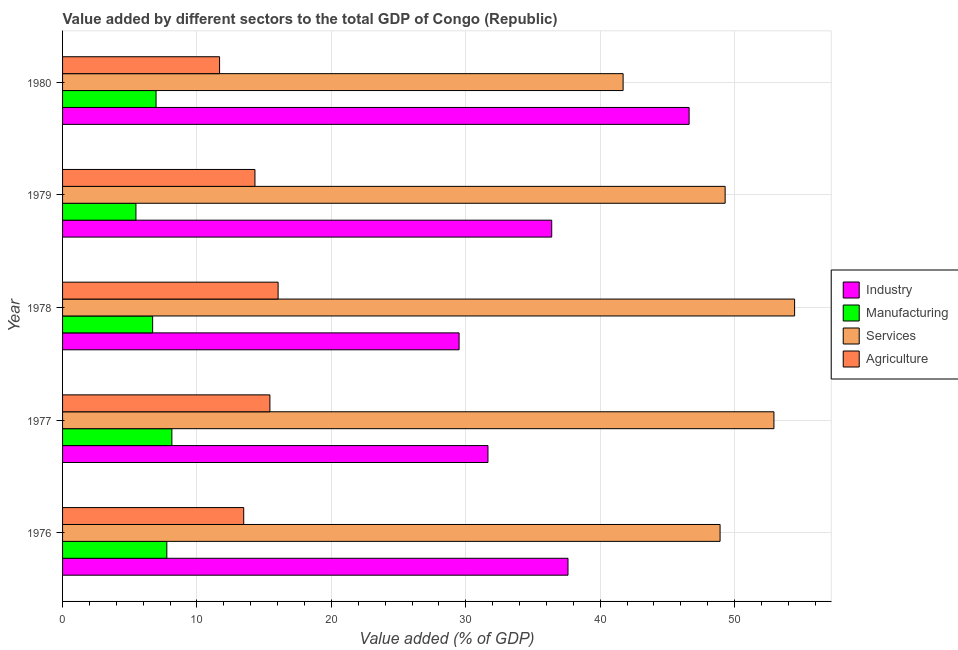How many groups of bars are there?
Provide a short and direct response. 5. Are the number of bars per tick equal to the number of legend labels?
Your response must be concise. Yes. Are the number of bars on each tick of the Y-axis equal?
Make the answer very short. Yes. What is the label of the 2nd group of bars from the top?
Make the answer very short. 1979. What is the value added by industrial sector in 1976?
Give a very brief answer. 37.6. Across all years, what is the maximum value added by services sector?
Provide a short and direct response. 54.46. Across all years, what is the minimum value added by industrial sector?
Offer a terse response. 29.5. In which year was the value added by agricultural sector maximum?
Make the answer very short. 1978. In which year was the value added by industrial sector minimum?
Give a very brief answer. 1978. What is the total value added by manufacturing sector in the graph?
Give a very brief answer. 35.01. What is the difference between the value added by industrial sector in 1977 and that in 1979?
Your answer should be very brief. -4.74. What is the difference between the value added by manufacturing sector in 1980 and the value added by industrial sector in 1979?
Offer a very short reply. -29.44. What is the average value added by manufacturing sector per year?
Your response must be concise. 7. In the year 1979, what is the difference between the value added by agricultural sector and value added by services sector?
Keep it short and to the point. -34.98. In how many years, is the value added by manufacturing sector greater than 42 %?
Make the answer very short. 0. Is the value added by services sector in 1978 less than that in 1979?
Your answer should be compact. No. What is the difference between the highest and the second highest value added by industrial sector?
Offer a very short reply. 9.01. What is the difference between the highest and the lowest value added by services sector?
Ensure brevity in your answer.  12.76. Is the sum of the value added by agricultural sector in 1976 and 1979 greater than the maximum value added by manufacturing sector across all years?
Your answer should be very brief. Yes. Is it the case that in every year, the sum of the value added by manufacturing sector and value added by agricultural sector is greater than the sum of value added by industrial sector and value added by services sector?
Ensure brevity in your answer.  No. What does the 1st bar from the top in 1977 represents?
Keep it short and to the point. Agriculture. What does the 2nd bar from the bottom in 1976 represents?
Give a very brief answer. Manufacturing. Is it the case that in every year, the sum of the value added by industrial sector and value added by manufacturing sector is greater than the value added by services sector?
Keep it short and to the point. No. Are all the bars in the graph horizontal?
Your answer should be compact. Yes. How many years are there in the graph?
Your answer should be very brief. 5. Does the graph contain any zero values?
Offer a terse response. No. Does the graph contain grids?
Your answer should be very brief. Yes. Where does the legend appear in the graph?
Your answer should be compact. Center right. How many legend labels are there?
Offer a terse response. 4. How are the legend labels stacked?
Your response must be concise. Vertical. What is the title of the graph?
Your answer should be very brief. Value added by different sectors to the total GDP of Congo (Republic). Does "Secondary vocational" appear as one of the legend labels in the graph?
Your answer should be compact. No. What is the label or title of the X-axis?
Offer a very short reply. Value added (% of GDP). What is the label or title of the Y-axis?
Your answer should be very brief. Year. What is the Value added (% of GDP) in Industry in 1976?
Your response must be concise. 37.6. What is the Value added (% of GDP) of Manufacturing in 1976?
Provide a succinct answer. 7.76. What is the Value added (% of GDP) in Services in 1976?
Your answer should be very brief. 48.92. What is the Value added (% of GDP) of Agriculture in 1976?
Your answer should be compact. 13.48. What is the Value added (% of GDP) in Industry in 1977?
Your answer should be compact. 31.65. What is the Value added (% of GDP) of Manufacturing in 1977?
Provide a succinct answer. 8.13. What is the Value added (% of GDP) of Services in 1977?
Make the answer very short. 52.93. What is the Value added (% of GDP) in Agriculture in 1977?
Offer a terse response. 15.43. What is the Value added (% of GDP) in Industry in 1978?
Make the answer very short. 29.5. What is the Value added (% of GDP) in Manufacturing in 1978?
Offer a terse response. 6.7. What is the Value added (% of GDP) in Services in 1978?
Make the answer very short. 54.46. What is the Value added (% of GDP) of Agriculture in 1978?
Offer a terse response. 16.04. What is the Value added (% of GDP) in Industry in 1979?
Offer a terse response. 36.39. What is the Value added (% of GDP) in Manufacturing in 1979?
Your answer should be very brief. 5.46. What is the Value added (% of GDP) of Services in 1979?
Keep it short and to the point. 49.29. What is the Value added (% of GDP) in Agriculture in 1979?
Keep it short and to the point. 14.31. What is the Value added (% of GDP) of Industry in 1980?
Provide a short and direct response. 46.61. What is the Value added (% of GDP) of Manufacturing in 1980?
Your answer should be compact. 6.96. What is the Value added (% of GDP) in Services in 1980?
Offer a terse response. 41.7. What is the Value added (% of GDP) in Agriculture in 1980?
Ensure brevity in your answer.  11.68. Across all years, what is the maximum Value added (% of GDP) in Industry?
Make the answer very short. 46.61. Across all years, what is the maximum Value added (% of GDP) in Manufacturing?
Your answer should be very brief. 8.13. Across all years, what is the maximum Value added (% of GDP) of Services?
Provide a succinct answer. 54.46. Across all years, what is the maximum Value added (% of GDP) of Agriculture?
Your answer should be very brief. 16.04. Across all years, what is the minimum Value added (% of GDP) in Industry?
Make the answer very short. 29.5. Across all years, what is the minimum Value added (% of GDP) of Manufacturing?
Offer a terse response. 5.46. Across all years, what is the minimum Value added (% of GDP) in Services?
Offer a terse response. 41.7. Across all years, what is the minimum Value added (% of GDP) in Agriculture?
Your response must be concise. 11.68. What is the total Value added (% of GDP) of Industry in the graph?
Your answer should be compact. 181.76. What is the total Value added (% of GDP) in Manufacturing in the graph?
Make the answer very short. 35.01. What is the total Value added (% of GDP) in Services in the graph?
Offer a very short reply. 247.3. What is the total Value added (% of GDP) in Agriculture in the graph?
Provide a succinct answer. 70.93. What is the difference between the Value added (% of GDP) of Industry in 1976 and that in 1977?
Ensure brevity in your answer.  5.96. What is the difference between the Value added (% of GDP) in Manufacturing in 1976 and that in 1977?
Make the answer very short. -0.38. What is the difference between the Value added (% of GDP) in Services in 1976 and that in 1977?
Ensure brevity in your answer.  -4.01. What is the difference between the Value added (% of GDP) in Agriculture in 1976 and that in 1977?
Keep it short and to the point. -1.95. What is the difference between the Value added (% of GDP) in Industry in 1976 and that in 1978?
Keep it short and to the point. 8.1. What is the difference between the Value added (% of GDP) of Manufacturing in 1976 and that in 1978?
Ensure brevity in your answer.  1.06. What is the difference between the Value added (% of GDP) in Services in 1976 and that in 1978?
Make the answer very short. -5.54. What is the difference between the Value added (% of GDP) in Agriculture in 1976 and that in 1978?
Offer a terse response. -2.56. What is the difference between the Value added (% of GDP) in Industry in 1976 and that in 1979?
Ensure brevity in your answer.  1.21. What is the difference between the Value added (% of GDP) of Manufacturing in 1976 and that in 1979?
Ensure brevity in your answer.  2.3. What is the difference between the Value added (% of GDP) of Services in 1976 and that in 1979?
Make the answer very short. -0.38. What is the difference between the Value added (% of GDP) of Agriculture in 1976 and that in 1979?
Make the answer very short. -0.84. What is the difference between the Value added (% of GDP) in Industry in 1976 and that in 1980?
Keep it short and to the point. -9.01. What is the difference between the Value added (% of GDP) in Manufacturing in 1976 and that in 1980?
Your answer should be very brief. 0.8. What is the difference between the Value added (% of GDP) in Services in 1976 and that in 1980?
Offer a terse response. 7.21. What is the difference between the Value added (% of GDP) of Agriculture in 1976 and that in 1980?
Ensure brevity in your answer.  1.8. What is the difference between the Value added (% of GDP) in Industry in 1977 and that in 1978?
Your answer should be very brief. 2.15. What is the difference between the Value added (% of GDP) of Manufacturing in 1977 and that in 1978?
Keep it short and to the point. 1.43. What is the difference between the Value added (% of GDP) of Services in 1977 and that in 1978?
Give a very brief answer. -1.54. What is the difference between the Value added (% of GDP) in Agriculture in 1977 and that in 1978?
Your answer should be very brief. -0.61. What is the difference between the Value added (% of GDP) of Industry in 1977 and that in 1979?
Your response must be concise. -4.74. What is the difference between the Value added (% of GDP) in Manufacturing in 1977 and that in 1979?
Provide a succinct answer. 2.67. What is the difference between the Value added (% of GDP) of Services in 1977 and that in 1979?
Your response must be concise. 3.63. What is the difference between the Value added (% of GDP) of Agriculture in 1977 and that in 1979?
Provide a short and direct response. 1.11. What is the difference between the Value added (% of GDP) in Industry in 1977 and that in 1980?
Provide a short and direct response. -14.97. What is the difference between the Value added (% of GDP) of Manufacturing in 1977 and that in 1980?
Your response must be concise. 1.18. What is the difference between the Value added (% of GDP) of Services in 1977 and that in 1980?
Your answer should be compact. 11.22. What is the difference between the Value added (% of GDP) of Agriculture in 1977 and that in 1980?
Your answer should be very brief. 3.74. What is the difference between the Value added (% of GDP) in Industry in 1978 and that in 1979?
Keep it short and to the point. -6.89. What is the difference between the Value added (% of GDP) of Manufacturing in 1978 and that in 1979?
Keep it short and to the point. 1.24. What is the difference between the Value added (% of GDP) in Services in 1978 and that in 1979?
Offer a very short reply. 5.17. What is the difference between the Value added (% of GDP) of Agriculture in 1978 and that in 1979?
Make the answer very short. 1.72. What is the difference between the Value added (% of GDP) in Industry in 1978 and that in 1980?
Give a very brief answer. -17.11. What is the difference between the Value added (% of GDP) of Manufacturing in 1978 and that in 1980?
Your answer should be compact. -0.25. What is the difference between the Value added (% of GDP) of Services in 1978 and that in 1980?
Keep it short and to the point. 12.76. What is the difference between the Value added (% of GDP) in Agriculture in 1978 and that in 1980?
Your answer should be compact. 4.35. What is the difference between the Value added (% of GDP) in Industry in 1979 and that in 1980?
Offer a very short reply. -10.22. What is the difference between the Value added (% of GDP) of Manufacturing in 1979 and that in 1980?
Provide a succinct answer. -1.5. What is the difference between the Value added (% of GDP) of Services in 1979 and that in 1980?
Offer a very short reply. 7.59. What is the difference between the Value added (% of GDP) in Agriculture in 1979 and that in 1980?
Keep it short and to the point. 2.63. What is the difference between the Value added (% of GDP) in Industry in 1976 and the Value added (% of GDP) in Manufacturing in 1977?
Your response must be concise. 29.47. What is the difference between the Value added (% of GDP) of Industry in 1976 and the Value added (% of GDP) of Services in 1977?
Your answer should be very brief. -15.32. What is the difference between the Value added (% of GDP) of Industry in 1976 and the Value added (% of GDP) of Agriculture in 1977?
Your answer should be compact. 22.18. What is the difference between the Value added (% of GDP) of Manufacturing in 1976 and the Value added (% of GDP) of Services in 1977?
Make the answer very short. -45.17. What is the difference between the Value added (% of GDP) of Manufacturing in 1976 and the Value added (% of GDP) of Agriculture in 1977?
Provide a short and direct response. -7.67. What is the difference between the Value added (% of GDP) of Services in 1976 and the Value added (% of GDP) of Agriculture in 1977?
Keep it short and to the point. 33.49. What is the difference between the Value added (% of GDP) in Industry in 1976 and the Value added (% of GDP) in Manufacturing in 1978?
Provide a short and direct response. 30.9. What is the difference between the Value added (% of GDP) in Industry in 1976 and the Value added (% of GDP) in Services in 1978?
Your answer should be very brief. -16.86. What is the difference between the Value added (% of GDP) in Industry in 1976 and the Value added (% of GDP) in Agriculture in 1978?
Your response must be concise. 21.57. What is the difference between the Value added (% of GDP) in Manufacturing in 1976 and the Value added (% of GDP) in Services in 1978?
Your answer should be very brief. -46.71. What is the difference between the Value added (% of GDP) in Manufacturing in 1976 and the Value added (% of GDP) in Agriculture in 1978?
Give a very brief answer. -8.28. What is the difference between the Value added (% of GDP) of Services in 1976 and the Value added (% of GDP) of Agriculture in 1978?
Provide a succinct answer. 32.88. What is the difference between the Value added (% of GDP) in Industry in 1976 and the Value added (% of GDP) in Manufacturing in 1979?
Give a very brief answer. 32.15. What is the difference between the Value added (% of GDP) in Industry in 1976 and the Value added (% of GDP) in Services in 1979?
Offer a terse response. -11.69. What is the difference between the Value added (% of GDP) in Industry in 1976 and the Value added (% of GDP) in Agriculture in 1979?
Offer a very short reply. 23.29. What is the difference between the Value added (% of GDP) in Manufacturing in 1976 and the Value added (% of GDP) in Services in 1979?
Keep it short and to the point. -41.54. What is the difference between the Value added (% of GDP) in Manufacturing in 1976 and the Value added (% of GDP) in Agriculture in 1979?
Make the answer very short. -6.56. What is the difference between the Value added (% of GDP) of Services in 1976 and the Value added (% of GDP) of Agriculture in 1979?
Your answer should be compact. 34.6. What is the difference between the Value added (% of GDP) in Industry in 1976 and the Value added (% of GDP) in Manufacturing in 1980?
Provide a short and direct response. 30.65. What is the difference between the Value added (% of GDP) of Industry in 1976 and the Value added (% of GDP) of Services in 1980?
Offer a terse response. -4.1. What is the difference between the Value added (% of GDP) in Industry in 1976 and the Value added (% of GDP) in Agriculture in 1980?
Offer a terse response. 25.92. What is the difference between the Value added (% of GDP) in Manufacturing in 1976 and the Value added (% of GDP) in Services in 1980?
Your response must be concise. -33.95. What is the difference between the Value added (% of GDP) in Manufacturing in 1976 and the Value added (% of GDP) in Agriculture in 1980?
Ensure brevity in your answer.  -3.92. What is the difference between the Value added (% of GDP) in Services in 1976 and the Value added (% of GDP) in Agriculture in 1980?
Ensure brevity in your answer.  37.24. What is the difference between the Value added (% of GDP) of Industry in 1977 and the Value added (% of GDP) of Manufacturing in 1978?
Offer a very short reply. 24.95. What is the difference between the Value added (% of GDP) in Industry in 1977 and the Value added (% of GDP) in Services in 1978?
Give a very brief answer. -22.81. What is the difference between the Value added (% of GDP) of Industry in 1977 and the Value added (% of GDP) of Agriculture in 1978?
Give a very brief answer. 15.61. What is the difference between the Value added (% of GDP) of Manufacturing in 1977 and the Value added (% of GDP) of Services in 1978?
Provide a short and direct response. -46.33. What is the difference between the Value added (% of GDP) in Manufacturing in 1977 and the Value added (% of GDP) in Agriculture in 1978?
Give a very brief answer. -7.9. What is the difference between the Value added (% of GDP) in Services in 1977 and the Value added (% of GDP) in Agriculture in 1978?
Provide a short and direct response. 36.89. What is the difference between the Value added (% of GDP) in Industry in 1977 and the Value added (% of GDP) in Manufacturing in 1979?
Offer a terse response. 26.19. What is the difference between the Value added (% of GDP) in Industry in 1977 and the Value added (% of GDP) in Services in 1979?
Offer a terse response. -17.65. What is the difference between the Value added (% of GDP) of Industry in 1977 and the Value added (% of GDP) of Agriculture in 1979?
Offer a very short reply. 17.34. What is the difference between the Value added (% of GDP) in Manufacturing in 1977 and the Value added (% of GDP) in Services in 1979?
Make the answer very short. -41.16. What is the difference between the Value added (% of GDP) of Manufacturing in 1977 and the Value added (% of GDP) of Agriculture in 1979?
Make the answer very short. -6.18. What is the difference between the Value added (% of GDP) of Services in 1977 and the Value added (% of GDP) of Agriculture in 1979?
Offer a very short reply. 38.61. What is the difference between the Value added (% of GDP) in Industry in 1977 and the Value added (% of GDP) in Manufacturing in 1980?
Make the answer very short. 24.69. What is the difference between the Value added (% of GDP) of Industry in 1977 and the Value added (% of GDP) of Services in 1980?
Make the answer very short. -10.05. What is the difference between the Value added (% of GDP) in Industry in 1977 and the Value added (% of GDP) in Agriculture in 1980?
Your answer should be compact. 19.97. What is the difference between the Value added (% of GDP) in Manufacturing in 1977 and the Value added (% of GDP) in Services in 1980?
Give a very brief answer. -33.57. What is the difference between the Value added (% of GDP) in Manufacturing in 1977 and the Value added (% of GDP) in Agriculture in 1980?
Offer a terse response. -3.55. What is the difference between the Value added (% of GDP) of Services in 1977 and the Value added (% of GDP) of Agriculture in 1980?
Your answer should be compact. 41.24. What is the difference between the Value added (% of GDP) of Industry in 1978 and the Value added (% of GDP) of Manufacturing in 1979?
Your answer should be very brief. 24.04. What is the difference between the Value added (% of GDP) in Industry in 1978 and the Value added (% of GDP) in Services in 1979?
Provide a succinct answer. -19.79. What is the difference between the Value added (% of GDP) in Industry in 1978 and the Value added (% of GDP) in Agriculture in 1979?
Ensure brevity in your answer.  15.19. What is the difference between the Value added (% of GDP) of Manufacturing in 1978 and the Value added (% of GDP) of Services in 1979?
Keep it short and to the point. -42.59. What is the difference between the Value added (% of GDP) in Manufacturing in 1978 and the Value added (% of GDP) in Agriculture in 1979?
Your answer should be compact. -7.61. What is the difference between the Value added (% of GDP) in Services in 1978 and the Value added (% of GDP) in Agriculture in 1979?
Provide a succinct answer. 40.15. What is the difference between the Value added (% of GDP) in Industry in 1978 and the Value added (% of GDP) in Manufacturing in 1980?
Your answer should be very brief. 22.54. What is the difference between the Value added (% of GDP) of Industry in 1978 and the Value added (% of GDP) of Services in 1980?
Provide a short and direct response. -12.2. What is the difference between the Value added (% of GDP) in Industry in 1978 and the Value added (% of GDP) in Agriculture in 1980?
Offer a very short reply. 17.82. What is the difference between the Value added (% of GDP) of Manufacturing in 1978 and the Value added (% of GDP) of Services in 1980?
Ensure brevity in your answer.  -35. What is the difference between the Value added (% of GDP) of Manufacturing in 1978 and the Value added (% of GDP) of Agriculture in 1980?
Offer a very short reply. -4.98. What is the difference between the Value added (% of GDP) of Services in 1978 and the Value added (% of GDP) of Agriculture in 1980?
Your answer should be very brief. 42.78. What is the difference between the Value added (% of GDP) in Industry in 1979 and the Value added (% of GDP) in Manufacturing in 1980?
Keep it short and to the point. 29.44. What is the difference between the Value added (% of GDP) in Industry in 1979 and the Value added (% of GDP) in Services in 1980?
Your response must be concise. -5.31. What is the difference between the Value added (% of GDP) of Industry in 1979 and the Value added (% of GDP) of Agriculture in 1980?
Provide a succinct answer. 24.71. What is the difference between the Value added (% of GDP) of Manufacturing in 1979 and the Value added (% of GDP) of Services in 1980?
Give a very brief answer. -36.25. What is the difference between the Value added (% of GDP) in Manufacturing in 1979 and the Value added (% of GDP) in Agriculture in 1980?
Your response must be concise. -6.22. What is the difference between the Value added (% of GDP) of Services in 1979 and the Value added (% of GDP) of Agriculture in 1980?
Offer a very short reply. 37.61. What is the average Value added (% of GDP) in Industry per year?
Keep it short and to the point. 36.35. What is the average Value added (% of GDP) of Manufacturing per year?
Offer a very short reply. 7. What is the average Value added (% of GDP) of Services per year?
Make the answer very short. 49.46. What is the average Value added (% of GDP) of Agriculture per year?
Offer a terse response. 14.19. In the year 1976, what is the difference between the Value added (% of GDP) in Industry and Value added (% of GDP) in Manufacturing?
Give a very brief answer. 29.85. In the year 1976, what is the difference between the Value added (% of GDP) of Industry and Value added (% of GDP) of Services?
Offer a terse response. -11.31. In the year 1976, what is the difference between the Value added (% of GDP) in Industry and Value added (% of GDP) in Agriculture?
Your answer should be very brief. 24.13. In the year 1976, what is the difference between the Value added (% of GDP) of Manufacturing and Value added (% of GDP) of Services?
Keep it short and to the point. -41.16. In the year 1976, what is the difference between the Value added (% of GDP) of Manufacturing and Value added (% of GDP) of Agriculture?
Give a very brief answer. -5.72. In the year 1976, what is the difference between the Value added (% of GDP) in Services and Value added (% of GDP) in Agriculture?
Keep it short and to the point. 35.44. In the year 1977, what is the difference between the Value added (% of GDP) in Industry and Value added (% of GDP) in Manufacturing?
Offer a terse response. 23.52. In the year 1977, what is the difference between the Value added (% of GDP) of Industry and Value added (% of GDP) of Services?
Ensure brevity in your answer.  -21.28. In the year 1977, what is the difference between the Value added (% of GDP) of Industry and Value added (% of GDP) of Agriculture?
Offer a terse response. 16.22. In the year 1977, what is the difference between the Value added (% of GDP) of Manufacturing and Value added (% of GDP) of Services?
Keep it short and to the point. -44.79. In the year 1977, what is the difference between the Value added (% of GDP) in Manufacturing and Value added (% of GDP) in Agriculture?
Give a very brief answer. -7.29. In the year 1977, what is the difference between the Value added (% of GDP) in Services and Value added (% of GDP) in Agriculture?
Keep it short and to the point. 37.5. In the year 1978, what is the difference between the Value added (% of GDP) in Industry and Value added (% of GDP) in Manufacturing?
Your answer should be compact. 22.8. In the year 1978, what is the difference between the Value added (% of GDP) of Industry and Value added (% of GDP) of Services?
Your answer should be compact. -24.96. In the year 1978, what is the difference between the Value added (% of GDP) of Industry and Value added (% of GDP) of Agriculture?
Ensure brevity in your answer.  13.46. In the year 1978, what is the difference between the Value added (% of GDP) in Manufacturing and Value added (% of GDP) in Services?
Your response must be concise. -47.76. In the year 1978, what is the difference between the Value added (% of GDP) of Manufacturing and Value added (% of GDP) of Agriculture?
Give a very brief answer. -9.33. In the year 1978, what is the difference between the Value added (% of GDP) of Services and Value added (% of GDP) of Agriculture?
Offer a terse response. 38.43. In the year 1979, what is the difference between the Value added (% of GDP) of Industry and Value added (% of GDP) of Manufacturing?
Your answer should be compact. 30.93. In the year 1979, what is the difference between the Value added (% of GDP) in Industry and Value added (% of GDP) in Services?
Make the answer very short. -12.9. In the year 1979, what is the difference between the Value added (% of GDP) in Industry and Value added (% of GDP) in Agriculture?
Provide a short and direct response. 22.08. In the year 1979, what is the difference between the Value added (% of GDP) in Manufacturing and Value added (% of GDP) in Services?
Keep it short and to the point. -43.84. In the year 1979, what is the difference between the Value added (% of GDP) in Manufacturing and Value added (% of GDP) in Agriculture?
Offer a very short reply. -8.86. In the year 1979, what is the difference between the Value added (% of GDP) in Services and Value added (% of GDP) in Agriculture?
Offer a terse response. 34.98. In the year 1980, what is the difference between the Value added (% of GDP) of Industry and Value added (% of GDP) of Manufacturing?
Your answer should be compact. 39.66. In the year 1980, what is the difference between the Value added (% of GDP) in Industry and Value added (% of GDP) in Services?
Ensure brevity in your answer.  4.91. In the year 1980, what is the difference between the Value added (% of GDP) in Industry and Value added (% of GDP) in Agriculture?
Keep it short and to the point. 34.93. In the year 1980, what is the difference between the Value added (% of GDP) of Manufacturing and Value added (% of GDP) of Services?
Make the answer very short. -34.75. In the year 1980, what is the difference between the Value added (% of GDP) in Manufacturing and Value added (% of GDP) in Agriculture?
Ensure brevity in your answer.  -4.73. In the year 1980, what is the difference between the Value added (% of GDP) of Services and Value added (% of GDP) of Agriculture?
Give a very brief answer. 30.02. What is the ratio of the Value added (% of GDP) of Industry in 1976 to that in 1977?
Ensure brevity in your answer.  1.19. What is the ratio of the Value added (% of GDP) in Manufacturing in 1976 to that in 1977?
Offer a very short reply. 0.95. What is the ratio of the Value added (% of GDP) of Services in 1976 to that in 1977?
Provide a short and direct response. 0.92. What is the ratio of the Value added (% of GDP) in Agriculture in 1976 to that in 1977?
Your answer should be very brief. 0.87. What is the ratio of the Value added (% of GDP) of Industry in 1976 to that in 1978?
Provide a short and direct response. 1.27. What is the ratio of the Value added (% of GDP) of Manufacturing in 1976 to that in 1978?
Provide a short and direct response. 1.16. What is the ratio of the Value added (% of GDP) in Services in 1976 to that in 1978?
Offer a terse response. 0.9. What is the ratio of the Value added (% of GDP) in Agriculture in 1976 to that in 1978?
Provide a short and direct response. 0.84. What is the ratio of the Value added (% of GDP) of Manufacturing in 1976 to that in 1979?
Ensure brevity in your answer.  1.42. What is the ratio of the Value added (% of GDP) of Agriculture in 1976 to that in 1979?
Offer a terse response. 0.94. What is the ratio of the Value added (% of GDP) of Industry in 1976 to that in 1980?
Offer a very short reply. 0.81. What is the ratio of the Value added (% of GDP) in Manufacturing in 1976 to that in 1980?
Keep it short and to the point. 1.12. What is the ratio of the Value added (% of GDP) in Services in 1976 to that in 1980?
Provide a short and direct response. 1.17. What is the ratio of the Value added (% of GDP) in Agriculture in 1976 to that in 1980?
Your response must be concise. 1.15. What is the ratio of the Value added (% of GDP) in Industry in 1977 to that in 1978?
Offer a very short reply. 1.07. What is the ratio of the Value added (% of GDP) of Manufacturing in 1977 to that in 1978?
Make the answer very short. 1.21. What is the ratio of the Value added (% of GDP) in Services in 1977 to that in 1978?
Your answer should be compact. 0.97. What is the ratio of the Value added (% of GDP) of Agriculture in 1977 to that in 1978?
Provide a succinct answer. 0.96. What is the ratio of the Value added (% of GDP) in Industry in 1977 to that in 1979?
Make the answer very short. 0.87. What is the ratio of the Value added (% of GDP) in Manufacturing in 1977 to that in 1979?
Your answer should be very brief. 1.49. What is the ratio of the Value added (% of GDP) in Services in 1977 to that in 1979?
Keep it short and to the point. 1.07. What is the ratio of the Value added (% of GDP) of Agriculture in 1977 to that in 1979?
Keep it short and to the point. 1.08. What is the ratio of the Value added (% of GDP) in Industry in 1977 to that in 1980?
Ensure brevity in your answer.  0.68. What is the ratio of the Value added (% of GDP) in Manufacturing in 1977 to that in 1980?
Make the answer very short. 1.17. What is the ratio of the Value added (% of GDP) in Services in 1977 to that in 1980?
Give a very brief answer. 1.27. What is the ratio of the Value added (% of GDP) of Agriculture in 1977 to that in 1980?
Keep it short and to the point. 1.32. What is the ratio of the Value added (% of GDP) in Industry in 1978 to that in 1979?
Your response must be concise. 0.81. What is the ratio of the Value added (% of GDP) in Manufacturing in 1978 to that in 1979?
Your answer should be very brief. 1.23. What is the ratio of the Value added (% of GDP) of Services in 1978 to that in 1979?
Offer a very short reply. 1.1. What is the ratio of the Value added (% of GDP) of Agriculture in 1978 to that in 1979?
Give a very brief answer. 1.12. What is the ratio of the Value added (% of GDP) in Industry in 1978 to that in 1980?
Your response must be concise. 0.63. What is the ratio of the Value added (% of GDP) of Manufacturing in 1978 to that in 1980?
Provide a short and direct response. 0.96. What is the ratio of the Value added (% of GDP) in Services in 1978 to that in 1980?
Ensure brevity in your answer.  1.31. What is the ratio of the Value added (% of GDP) of Agriculture in 1978 to that in 1980?
Give a very brief answer. 1.37. What is the ratio of the Value added (% of GDP) in Industry in 1979 to that in 1980?
Your answer should be compact. 0.78. What is the ratio of the Value added (% of GDP) in Manufacturing in 1979 to that in 1980?
Provide a short and direct response. 0.78. What is the ratio of the Value added (% of GDP) of Services in 1979 to that in 1980?
Offer a terse response. 1.18. What is the ratio of the Value added (% of GDP) of Agriculture in 1979 to that in 1980?
Your response must be concise. 1.23. What is the difference between the highest and the second highest Value added (% of GDP) in Industry?
Make the answer very short. 9.01. What is the difference between the highest and the second highest Value added (% of GDP) of Manufacturing?
Your answer should be compact. 0.38. What is the difference between the highest and the second highest Value added (% of GDP) of Services?
Your answer should be compact. 1.54. What is the difference between the highest and the second highest Value added (% of GDP) of Agriculture?
Offer a very short reply. 0.61. What is the difference between the highest and the lowest Value added (% of GDP) of Industry?
Your response must be concise. 17.11. What is the difference between the highest and the lowest Value added (% of GDP) of Manufacturing?
Your response must be concise. 2.67. What is the difference between the highest and the lowest Value added (% of GDP) of Services?
Provide a succinct answer. 12.76. What is the difference between the highest and the lowest Value added (% of GDP) in Agriculture?
Ensure brevity in your answer.  4.35. 